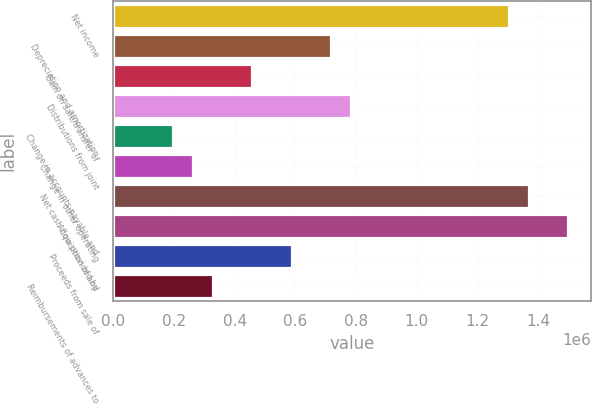Convert chart to OTSL. <chart><loc_0><loc_0><loc_500><loc_500><bar_chart><fcel>Net income<fcel>Depreciation and amortization<fcel>Gain on sale/transfer of<fcel>Distributions from joint<fcel>Change in accounts payable and<fcel>Change in other operating<fcel>Net cash flow provided by<fcel>Acquisition of and<fcel>Proceeds from sale of<fcel>Reimbursements of advances to<nl><fcel>1.30351e+06<fcel>718248<fcel>458131<fcel>783278<fcel>198014<fcel>263043<fcel>1.36854e+06<fcel>1.4986e+06<fcel>588190<fcel>328072<nl></chart> 